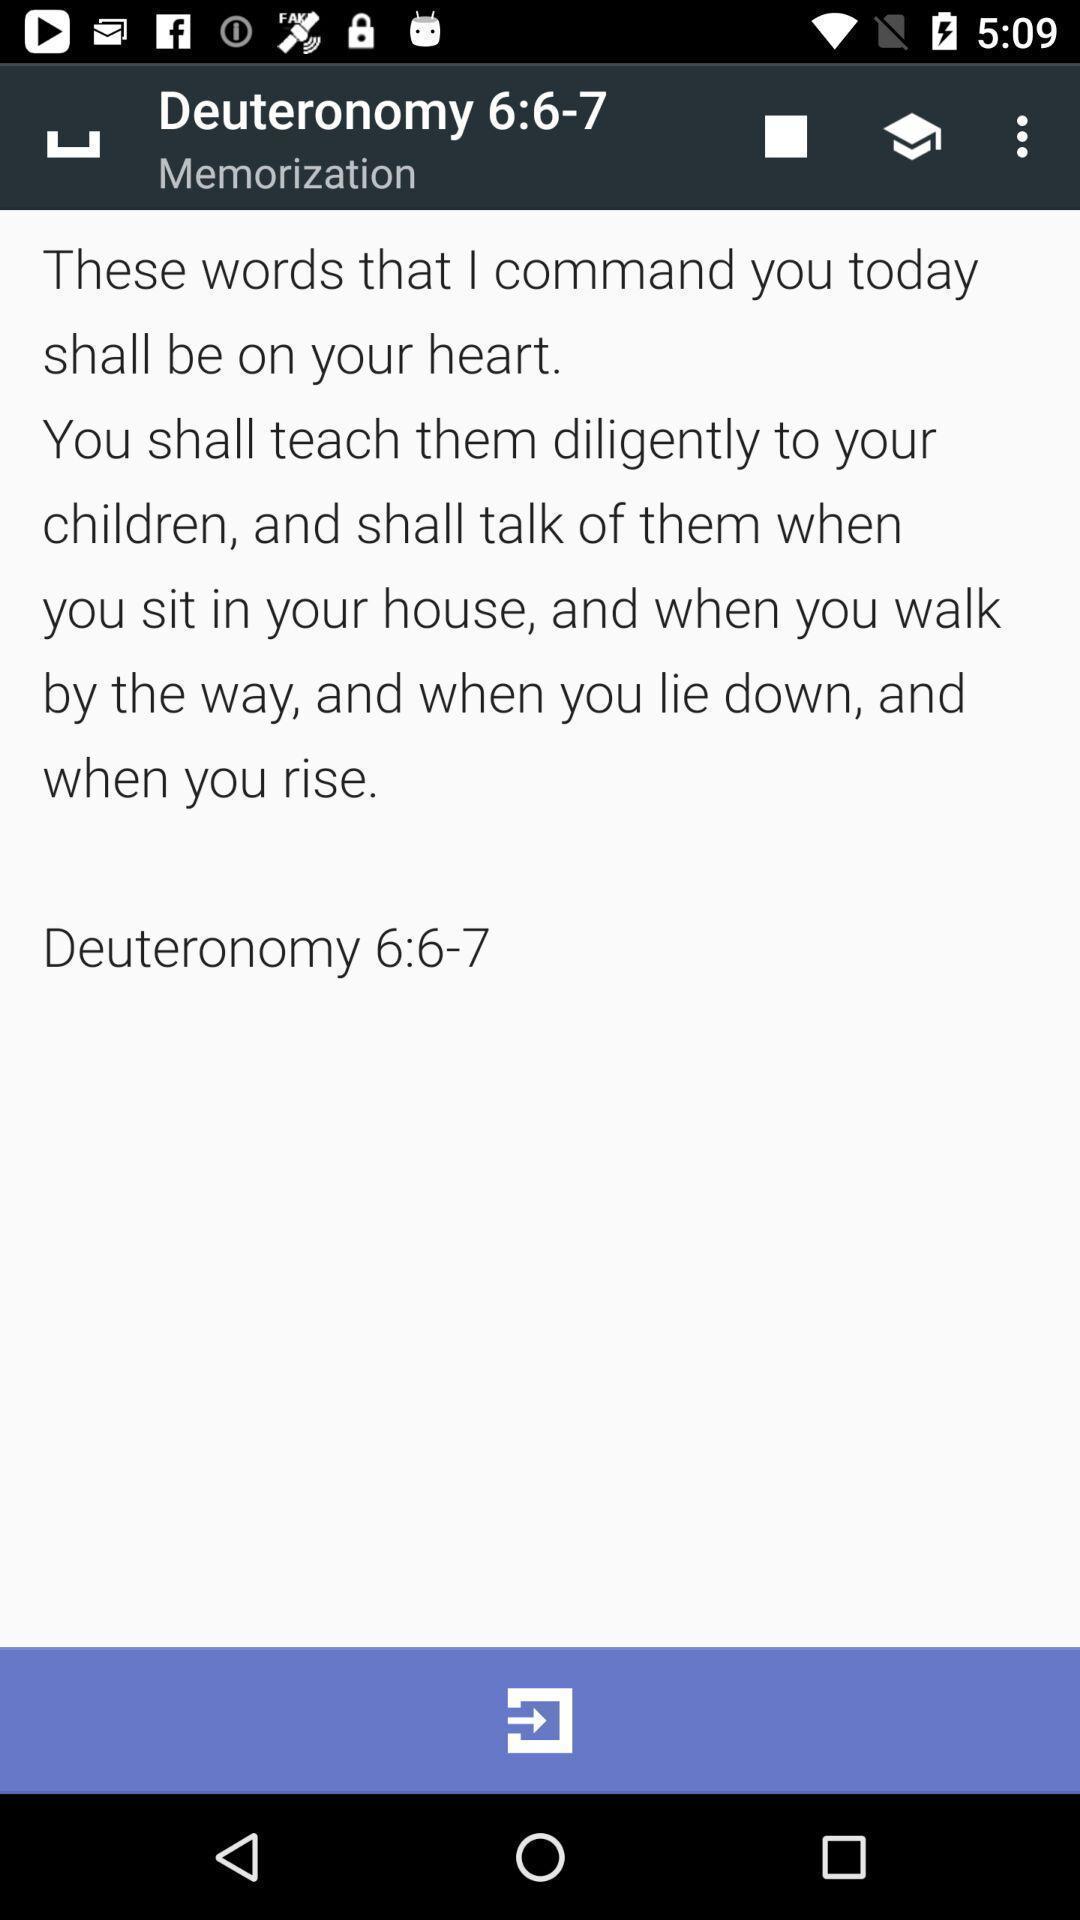Tell me what you see in this picture. Page in a holy book app. 